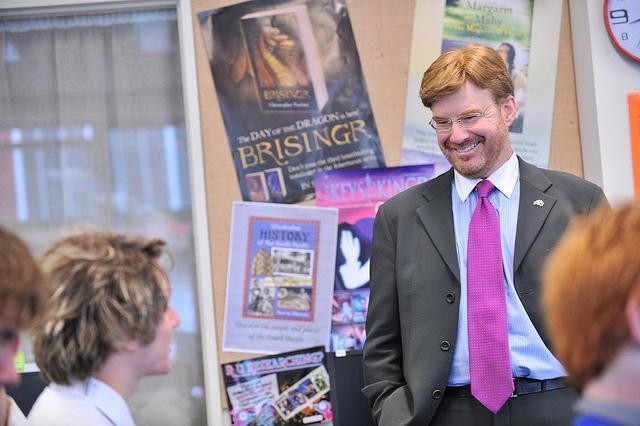How many people are in the picture?
Give a very brief answer. 4. 